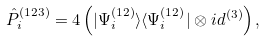Convert formula to latex. <formula><loc_0><loc_0><loc_500><loc_500>\hat { P } _ { i } ^ { ( 1 2 3 ) } = 4 \left ( | \Psi _ { i } ^ { ( 1 2 ) } \rangle \langle \Psi _ { i } ^ { ( 1 2 ) } | \otimes i d ^ { ( 3 ) } \right ) ,</formula> 